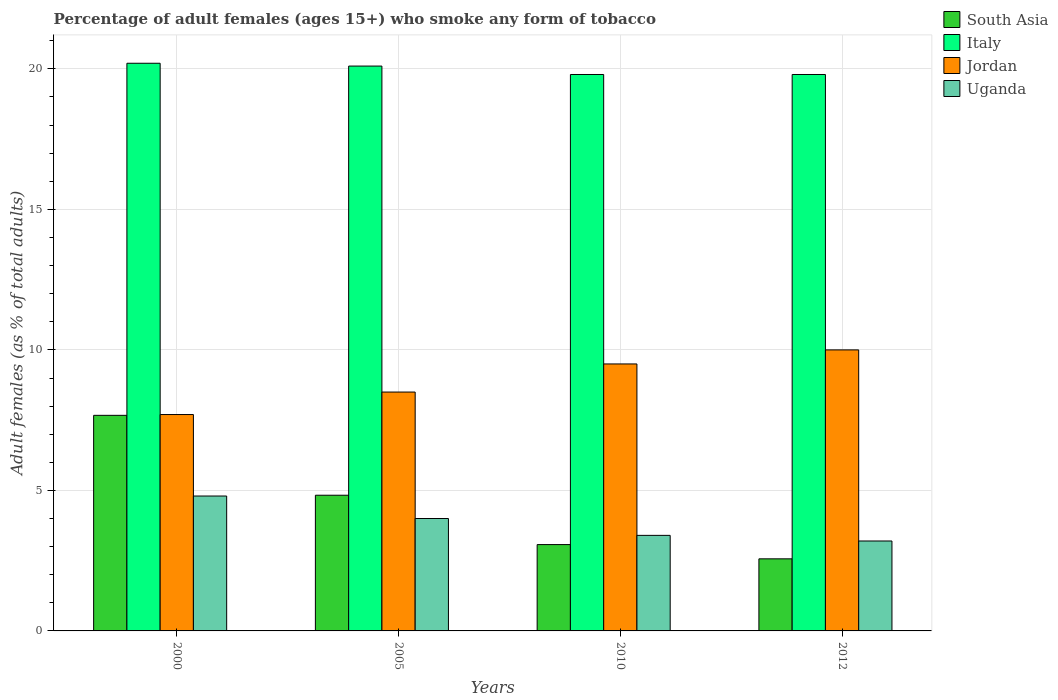How many groups of bars are there?
Ensure brevity in your answer.  4. Are the number of bars per tick equal to the number of legend labels?
Your response must be concise. Yes. Are the number of bars on each tick of the X-axis equal?
Offer a terse response. Yes. In how many cases, is the number of bars for a given year not equal to the number of legend labels?
Provide a succinct answer. 0. What is the percentage of adult females who smoke in South Asia in 2000?
Make the answer very short. 7.67. Across all years, what is the minimum percentage of adult females who smoke in South Asia?
Offer a very short reply. 2.56. In which year was the percentage of adult females who smoke in Uganda maximum?
Your answer should be compact. 2000. What is the total percentage of adult females who smoke in Uganda in the graph?
Keep it short and to the point. 15.4. What is the difference between the percentage of adult females who smoke in Uganda in 2000 and that in 2012?
Make the answer very short. 1.6. What is the difference between the percentage of adult females who smoke in Italy in 2005 and the percentage of adult females who smoke in Uganda in 2012?
Your response must be concise. 16.9. What is the average percentage of adult females who smoke in Italy per year?
Offer a very short reply. 19.97. In the year 2000, what is the difference between the percentage of adult females who smoke in Italy and percentage of adult females who smoke in South Asia?
Ensure brevity in your answer.  12.53. In how many years, is the percentage of adult females who smoke in Italy greater than 1 %?
Offer a very short reply. 4. What is the ratio of the percentage of adult females who smoke in Italy in 2000 to that in 2010?
Your answer should be very brief. 1.02. Is the percentage of adult females who smoke in Jordan in 2000 less than that in 2010?
Your answer should be very brief. Yes. What is the difference between the highest and the second highest percentage of adult females who smoke in South Asia?
Your response must be concise. 2.84. What is the difference between the highest and the lowest percentage of adult females who smoke in Italy?
Your response must be concise. 0.4. Is the sum of the percentage of adult females who smoke in Uganda in 2000 and 2005 greater than the maximum percentage of adult females who smoke in Jordan across all years?
Your answer should be compact. No. Is it the case that in every year, the sum of the percentage of adult females who smoke in Uganda and percentage of adult females who smoke in Jordan is greater than the sum of percentage of adult females who smoke in South Asia and percentage of adult females who smoke in Italy?
Your answer should be compact. Yes. What does the 4th bar from the left in 2005 represents?
Your answer should be very brief. Uganda. What does the 3rd bar from the right in 2000 represents?
Provide a short and direct response. Italy. Are all the bars in the graph horizontal?
Offer a terse response. No. How many years are there in the graph?
Give a very brief answer. 4. What is the difference between two consecutive major ticks on the Y-axis?
Make the answer very short. 5. Does the graph contain any zero values?
Your answer should be compact. No. Does the graph contain grids?
Provide a succinct answer. Yes. Where does the legend appear in the graph?
Your answer should be compact. Top right. How many legend labels are there?
Provide a short and direct response. 4. What is the title of the graph?
Ensure brevity in your answer.  Percentage of adult females (ages 15+) who smoke any form of tobacco. Does "New Zealand" appear as one of the legend labels in the graph?
Your answer should be compact. No. What is the label or title of the Y-axis?
Provide a short and direct response. Adult females (as % of total adults). What is the Adult females (as % of total adults) of South Asia in 2000?
Provide a succinct answer. 7.67. What is the Adult females (as % of total adults) of Italy in 2000?
Provide a succinct answer. 20.2. What is the Adult females (as % of total adults) in Uganda in 2000?
Offer a very short reply. 4.8. What is the Adult females (as % of total adults) of South Asia in 2005?
Make the answer very short. 4.83. What is the Adult females (as % of total adults) in Italy in 2005?
Offer a terse response. 20.1. What is the Adult females (as % of total adults) in Uganda in 2005?
Your answer should be very brief. 4. What is the Adult females (as % of total adults) of South Asia in 2010?
Ensure brevity in your answer.  3.07. What is the Adult females (as % of total adults) in Italy in 2010?
Offer a very short reply. 19.8. What is the Adult females (as % of total adults) in Jordan in 2010?
Offer a very short reply. 9.5. What is the Adult females (as % of total adults) of South Asia in 2012?
Offer a terse response. 2.56. What is the Adult females (as % of total adults) in Italy in 2012?
Provide a succinct answer. 19.8. What is the Adult females (as % of total adults) of Uganda in 2012?
Provide a short and direct response. 3.2. Across all years, what is the maximum Adult females (as % of total adults) in South Asia?
Offer a terse response. 7.67. Across all years, what is the maximum Adult females (as % of total adults) of Italy?
Your response must be concise. 20.2. Across all years, what is the maximum Adult females (as % of total adults) of Uganda?
Provide a succinct answer. 4.8. Across all years, what is the minimum Adult females (as % of total adults) of South Asia?
Ensure brevity in your answer.  2.56. Across all years, what is the minimum Adult females (as % of total adults) of Italy?
Your response must be concise. 19.8. Across all years, what is the minimum Adult females (as % of total adults) of Uganda?
Your response must be concise. 3.2. What is the total Adult females (as % of total adults) in South Asia in the graph?
Your answer should be compact. 18.14. What is the total Adult females (as % of total adults) in Italy in the graph?
Give a very brief answer. 79.9. What is the total Adult females (as % of total adults) in Jordan in the graph?
Make the answer very short. 35.7. What is the difference between the Adult females (as % of total adults) in South Asia in 2000 and that in 2005?
Your answer should be very brief. 2.84. What is the difference between the Adult females (as % of total adults) in Uganda in 2000 and that in 2005?
Offer a very short reply. 0.8. What is the difference between the Adult females (as % of total adults) in South Asia in 2000 and that in 2010?
Ensure brevity in your answer.  4.6. What is the difference between the Adult females (as % of total adults) in Jordan in 2000 and that in 2010?
Provide a succinct answer. -1.8. What is the difference between the Adult females (as % of total adults) in South Asia in 2000 and that in 2012?
Ensure brevity in your answer.  5.11. What is the difference between the Adult females (as % of total adults) in Italy in 2000 and that in 2012?
Your answer should be compact. 0.4. What is the difference between the Adult females (as % of total adults) in Jordan in 2000 and that in 2012?
Your answer should be very brief. -2.3. What is the difference between the Adult females (as % of total adults) in South Asia in 2005 and that in 2010?
Offer a very short reply. 1.76. What is the difference between the Adult females (as % of total adults) of Italy in 2005 and that in 2010?
Make the answer very short. 0.3. What is the difference between the Adult females (as % of total adults) of Uganda in 2005 and that in 2010?
Provide a short and direct response. 0.6. What is the difference between the Adult females (as % of total adults) in South Asia in 2005 and that in 2012?
Keep it short and to the point. 2.26. What is the difference between the Adult females (as % of total adults) in Italy in 2005 and that in 2012?
Offer a terse response. 0.3. What is the difference between the Adult females (as % of total adults) in Uganda in 2005 and that in 2012?
Offer a very short reply. 0.8. What is the difference between the Adult females (as % of total adults) in South Asia in 2010 and that in 2012?
Your response must be concise. 0.51. What is the difference between the Adult females (as % of total adults) of Jordan in 2010 and that in 2012?
Your answer should be compact. -0.5. What is the difference between the Adult females (as % of total adults) of Uganda in 2010 and that in 2012?
Your response must be concise. 0.2. What is the difference between the Adult females (as % of total adults) in South Asia in 2000 and the Adult females (as % of total adults) in Italy in 2005?
Your answer should be very brief. -12.43. What is the difference between the Adult females (as % of total adults) in South Asia in 2000 and the Adult females (as % of total adults) in Jordan in 2005?
Provide a short and direct response. -0.83. What is the difference between the Adult females (as % of total adults) in South Asia in 2000 and the Adult females (as % of total adults) in Uganda in 2005?
Offer a very short reply. 3.67. What is the difference between the Adult females (as % of total adults) of Italy in 2000 and the Adult females (as % of total adults) of Uganda in 2005?
Keep it short and to the point. 16.2. What is the difference between the Adult females (as % of total adults) of Jordan in 2000 and the Adult females (as % of total adults) of Uganda in 2005?
Provide a succinct answer. 3.7. What is the difference between the Adult females (as % of total adults) of South Asia in 2000 and the Adult females (as % of total adults) of Italy in 2010?
Your answer should be very brief. -12.13. What is the difference between the Adult females (as % of total adults) in South Asia in 2000 and the Adult females (as % of total adults) in Jordan in 2010?
Your answer should be very brief. -1.83. What is the difference between the Adult females (as % of total adults) in South Asia in 2000 and the Adult females (as % of total adults) in Uganda in 2010?
Your answer should be compact. 4.27. What is the difference between the Adult females (as % of total adults) of Italy in 2000 and the Adult females (as % of total adults) of Uganda in 2010?
Make the answer very short. 16.8. What is the difference between the Adult females (as % of total adults) of Jordan in 2000 and the Adult females (as % of total adults) of Uganda in 2010?
Keep it short and to the point. 4.3. What is the difference between the Adult females (as % of total adults) of South Asia in 2000 and the Adult females (as % of total adults) of Italy in 2012?
Your answer should be compact. -12.13. What is the difference between the Adult females (as % of total adults) of South Asia in 2000 and the Adult females (as % of total adults) of Jordan in 2012?
Provide a short and direct response. -2.33. What is the difference between the Adult females (as % of total adults) in South Asia in 2000 and the Adult females (as % of total adults) in Uganda in 2012?
Provide a succinct answer. 4.47. What is the difference between the Adult females (as % of total adults) of Italy in 2000 and the Adult females (as % of total adults) of Jordan in 2012?
Keep it short and to the point. 10.2. What is the difference between the Adult females (as % of total adults) of Italy in 2000 and the Adult females (as % of total adults) of Uganda in 2012?
Your answer should be very brief. 17. What is the difference between the Adult females (as % of total adults) of South Asia in 2005 and the Adult females (as % of total adults) of Italy in 2010?
Ensure brevity in your answer.  -14.97. What is the difference between the Adult females (as % of total adults) in South Asia in 2005 and the Adult females (as % of total adults) in Jordan in 2010?
Ensure brevity in your answer.  -4.67. What is the difference between the Adult females (as % of total adults) of South Asia in 2005 and the Adult females (as % of total adults) of Uganda in 2010?
Provide a succinct answer. 1.43. What is the difference between the Adult females (as % of total adults) in Italy in 2005 and the Adult females (as % of total adults) in Jordan in 2010?
Provide a succinct answer. 10.6. What is the difference between the Adult females (as % of total adults) of Italy in 2005 and the Adult females (as % of total adults) of Uganda in 2010?
Your response must be concise. 16.7. What is the difference between the Adult females (as % of total adults) in Jordan in 2005 and the Adult females (as % of total adults) in Uganda in 2010?
Your answer should be very brief. 5.1. What is the difference between the Adult females (as % of total adults) of South Asia in 2005 and the Adult females (as % of total adults) of Italy in 2012?
Give a very brief answer. -14.97. What is the difference between the Adult females (as % of total adults) of South Asia in 2005 and the Adult females (as % of total adults) of Jordan in 2012?
Provide a short and direct response. -5.17. What is the difference between the Adult females (as % of total adults) in South Asia in 2005 and the Adult females (as % of total adults) in Uganda in 2012?
Your response must be concise. 1.63. What is the difference between the Adult females (as % of total adults) in Italy in 2005 and the Adult females (as % of total adults) in Jordan in 2012?
Provide a succinct answer. 10.1. What is the difference between the Adult females (as % of total adults) of South Asia in 2010 and the Adult females (as % of total adults) of Italy in 2012?
Make the answer very short. -16.73. What is the difference between the Adult females (as % of total adults) in South Asia in 2010 and the Adult females (as % of total adults) in Jordan in 2012?
Keep it short and to the point. -6.93. What is the difference between the Adult females (as % of total adults) of South Asia in 2010 and the Adult females (as % of total adults) of Uganda in 2012?
Your answer should be very brief. -0.13. What is the difference between the Adult females (as % of total adults) in Italy in 2010 and the Adult females (as % of total adults) in Jordan in 2012?
Give a very brief answer. 9.8. What is the difference between the Adult females (as % of total adults) of Italy in 2010 and the Adult females (as % of total adults) of Uganda in 2012?
Ensure brevity in your answer.  16.6. What is the average Adult females (as % of total adults) in South Asia per year?
Provide a short and direct response. 4.53. What is the average Adult females (as % of total adults) of Italy per year?
Provide a succinct answer. 19.98. What is the average Adult females (as % of total adults) of Jordan per year?
Your answer should be compact. 8.93. What is the average Adult females (as % of total adults) in Uganda per year?
Give a very brief answer. 3.85. In the year 2000, what is the difference between the Adult females (as % of total adults) of South Asia and Adult females (as % of total adults) of Italy?
Offer a terse response. -12.53. In the year 2000, what is the difference between the Adult females (as % of total adults) in South Asia and Adult females (as % of total adults) in Jordan?
Provide a succinct answer. -0.03. In the year 2000, what is the difference between the Adult females (as % of total adults) in South Asia and Adult females (as % of total adults) in Uganda?
Your response must be concise. 2.87. In the year 2000, what is the difference between the Adult females (as % of total adults) of Italy and Adult females (as % of total adults) of Jordan?
Make the answer very short. 12.5. In the year 2000, what is the difference between the Adult females (as % of total adults) of Italy and Adult females (as % of total adults) of Uganda?
Your answer should be compact. 15.4. In the year 2005, what is the difference between the Adult females (as % of total adults) in South Asia and Adult females (as % of total adults) in Italy?
Your answer should be compact. -15.27. In the year 2005, what is the difference between the Adult females (as % of total adults) of South Asia and Adult females (as % of total adults) of Jordan?
Your answer should be compact. -3.67. In the year 2005, what is the difference between the Adult females (as % of total adults) in South Asia and Adult females (as % of total adults) in Uganda?
Provide a short and direct response. 0.83. In the year 2005, what is the difference between the Adult females (as % of total adults) in Italy and Adult females (as % of total adults) in Jordan?
Provide a succinct answer. 11.6. In the year 2005, what is the difference between the Adult females (as % of total adults) of Italy and Adult females (as % of total adults) of Uganda?
Your answer should be compact. 16.1. In the year 2010, what is the difference between the Adult females (as % of total adults) in South Asia and Adult females (as % of total adults) in Italy?
Make the answer very short. -16.73. In the year 2010, what is the difference between the Adult females (as % of total adults) in South Asia and Adult females (as % of total adults) in Jordan?
Your response must be concise. -6.43. In the year 2010, what is the difference between the Adult females (as % of total adults) of South Asia and Adult females (as % of total adults) of Uganda?
Give a very brief answer. -0.33. In the year 2012, what is the difference between the Adult females (as % of total adults) in South Asia and Adult females (as % of total adults) in Italy?
Your answer should be compact. -17.24. In the year 2012, what is the difference between the Adult females (as % of total adults) in South Asia and Adult females (as % of total adults) in Jordan?
Your response must be concise. -7.44. In the year 2012, what is the difference between the Adult females (as % of total adults) in South Asia and Adult females (as % of total adults) in Uganda?
Offer a very short reply. -0.64. In the year 2012, what is the difference between the Adult females (as % of total adults) in Italy and Adult females (as % of total adults) in Jordan?
Your response must be concise. 9.8. In the year 2012, what is the difference between the Adult females (as % of total adults) of Italy and Adult females (as % of total adults) of Uganda?
Your response must be concise. 16.6. In the year 2012, what is the difference between the Adult females (as % of total adults) of Jordan and Adult females (as % of total adults) of Uganda?
Ensure brevity in your answer.  6.8. What is the ratio of the Adult females (as % of total adults) in South Asia in 2000 to that in 2005?
Ensure brevity in your answer.  1.59. What is the ratio of the Adult females (as % of total adults) in Jordan in 2000 to that in 2005?
Offer a terse response. 0.91. What is the ratio of the Adult females (as % of total adults) of South Asia in 2000 to that in 2010?
Make the answer very short. 2.5. What is the ratio of the Adult females (as % of total adults) in Italy in 2000 to that in 2010?
Give a very brief answer. 1.02. What is the ratio of the Adult females (as % of total adults) of Jordan in 2000 to that in 2010?
Provide a short and direct response. 0.81. What is the ratio of the Adult females (as % of total adults) of Uganda in 2000 to that in 2010?
Offer a very short reply. 1.41. What is the ratio of the Adult females (as % of total adults) of South Asia in 2000 to that in 2012?
Ensure brevity in your answer.  2.99. What is the ratio of the Adult females (as % of total adults) of Italy in 2000 to that in 2012?
Ensure brevity in your answer.  1.02. What is the ratio of the Adult females (as % of total adults) of Jordan in 2000 to that in 2012?
Your answer should be compact. 0.77. What is the ratio of the Adult females (as % of total adults) in Uganda in 2000 to that in 2012?
Ensure brevity in your answer.  1.5. What is the ratio of the Adult females (as % of total adults) in South Asia in 2005 to that in 2010?
Your answer should be very brief. 1.57. What is the ratio of the Adult females (as % of total adults) of Italy in 2005 to that in 2010?
Provide a succinct answer. 1.02. What is the ratio of the Adult females (as % of total adults) in Jordan in 2005 to that in 2010?
Ensure brevity in your answer.  0.89. What is the ratio of the Adult females (as % of total adults) of Uganda in 2005 to that in 2010?
Give a very brief answer. 1.18. What is the ratio of the Adult females (as % of total adults) of South Asia in 2005 to that in 2012?
Offer a terse response. 1.88. What is the ratio of the Adult females (as % of total adults) in Italy in 2005 to that in 2012?
Your response must be concise. 1.02. What is the ratio of the Adult females (as % of total adults) of Jordan in 2005 to that in 2012?
Ensure brevity in your answer.  0.85. What is the ratio of the Adult females (as % of total adults) of South Asia in 2010 to that in 2012?
Your response must be concise. 1.2. What is the ratio of the Adult females (as % of total adults) of Italy in 2010 to that in 2012?
Keep it short and to the point. 1. What is the difference between the highest and the second highest Adult females (as % of total adults) in South Asia?
Make the answer very short. 2.84. What is the difference between the highest and the second highest Adult females (as % of total adults) in Jordan?
Give a very brief answer. 0.5. What is the difference between the highest and the lowest Adult females (as % of total adults) in South Asia?
Give a very brief answer. 5.11. 